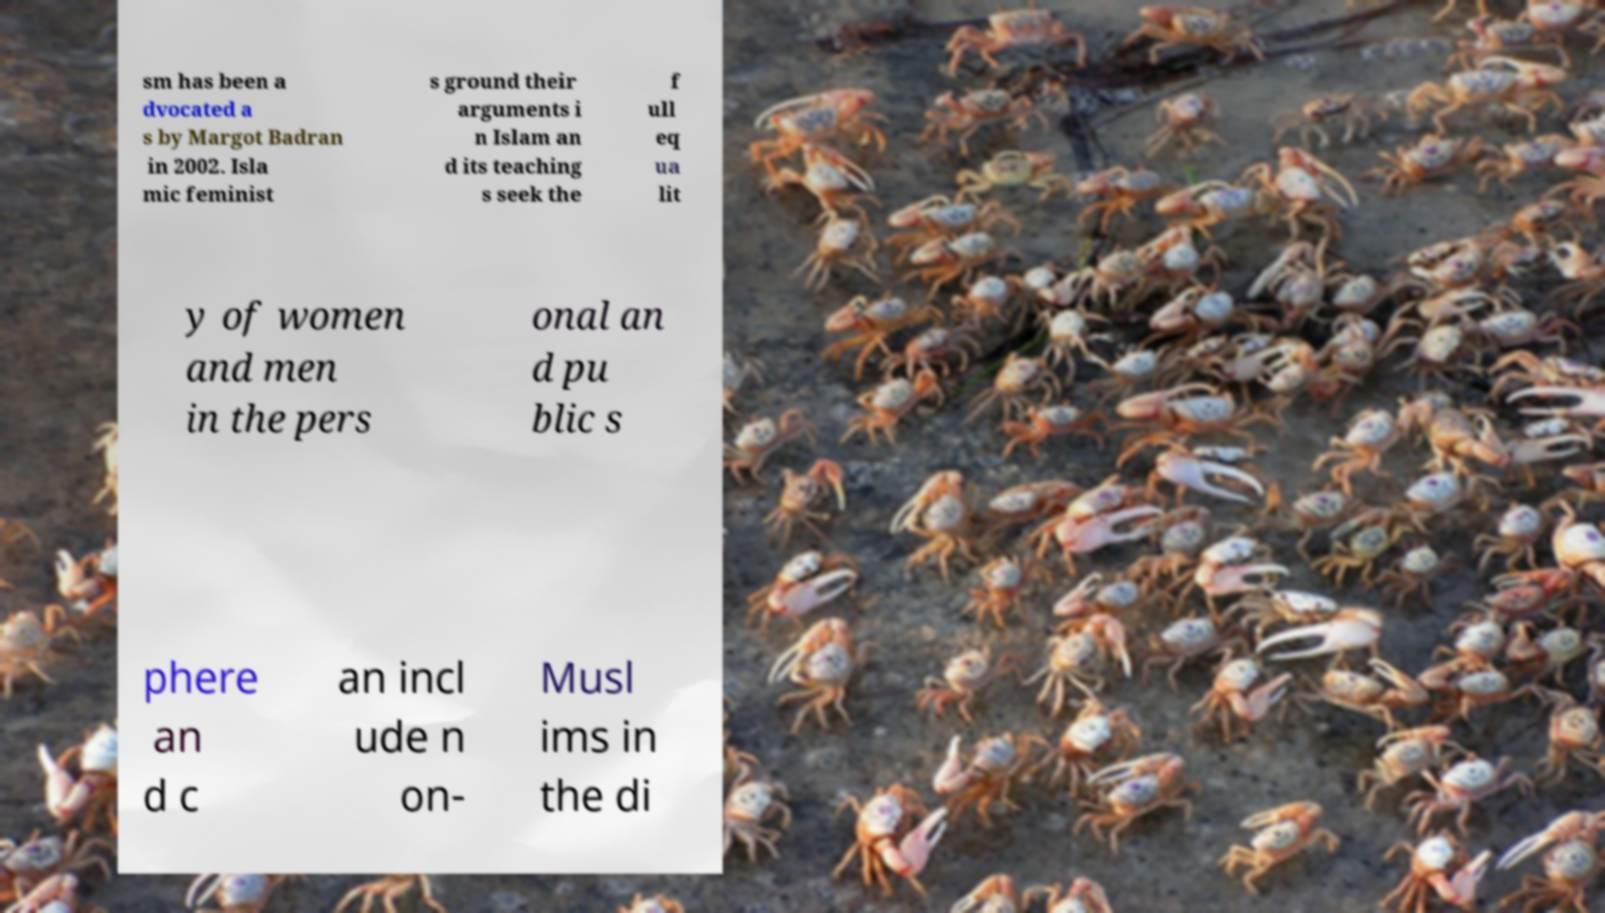Could you extract and type out the text from this image? sm has been a dvocated a s by Margot Badran in 2002. Isla mic feminist s ground their arguments i n Islam an d its teaching s seek the f ull eq ua lit y of women and men in the pers onal an d pu blic s phere an d c an incl ude n on- Musl ims in the di 